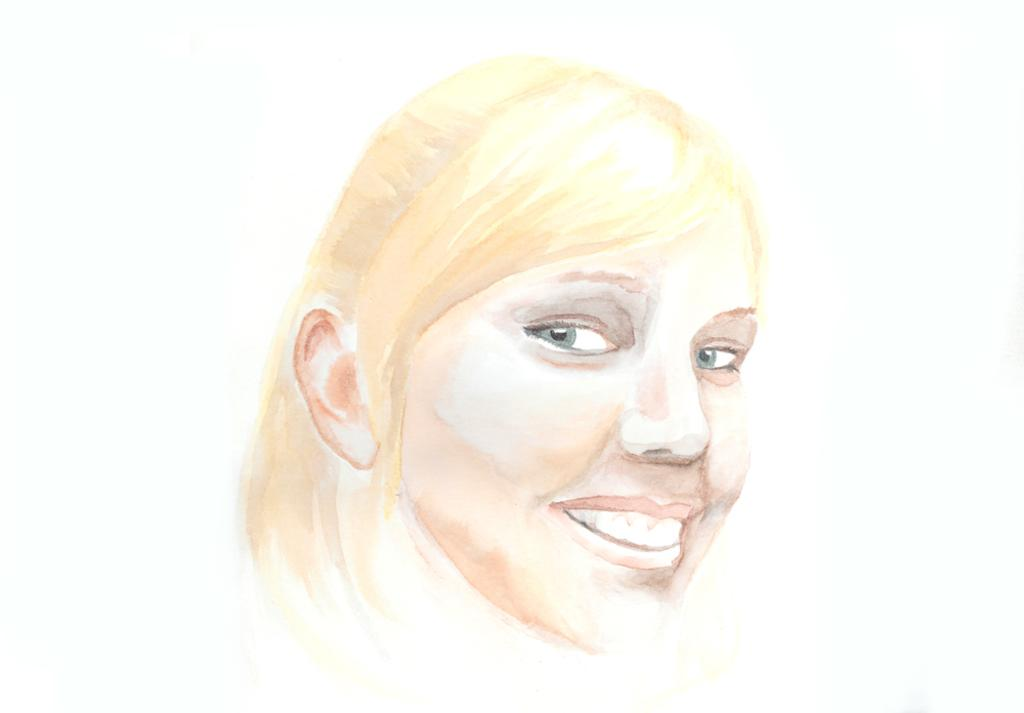What is the main subject of the image? There is a painting in the image. What is depicted in the painting? The painting depicts a woman. What expression does the woman in the painting have? The woman in the painting is smiling. What type of toys can be seen in the painting? There are no toys present in the painting; it depicts a woman. What color is the woman's lip in the painting? The provided facts do not mention the color of the woman's lip in the painting. 